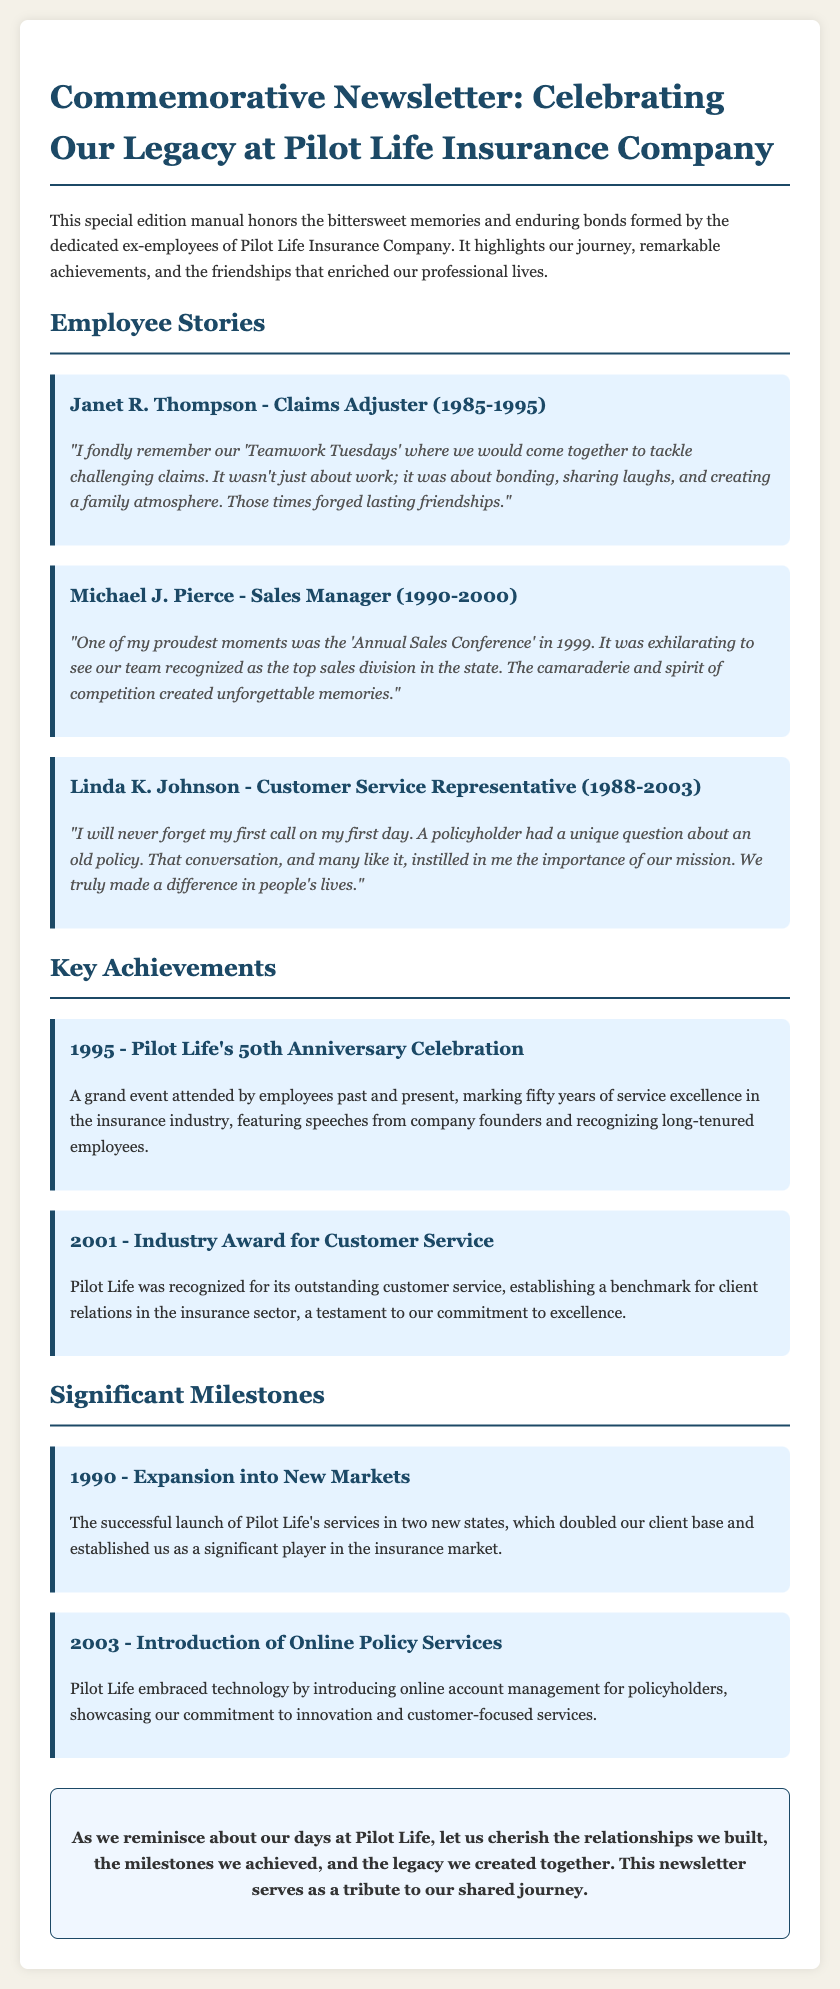What is the title of the newsletter? The title of the newsletter is stated in the header of the document.
Answer: Commemorative Newsletter: Celebrating Our Legacy at Pilot Life Insurance Company Who reminisced about 'Teamwork Tuesdays'? This person's memories are documented under the Employee Stories section.
Answer: Janet R. Thompson In which year was the 50th Anniversary Celebration held? The year of the anniversary celebration is presented under Key Achievements.
Answer: 1995 What significant event happened in 2001? This event is listed as a key achievement within the document.
Answer: Industry Award for Customer Service How many states did Pilot Life expand into in 1990? The information is provided under Significant Milestones.
Answer: Two What was introduced in 2003 to showcase innovation? This detail is included in the milestones section of the document.
Answer: Online Policy Services Which employee served as a Sales Manager? The job title is featured in the Employee Stories section.
Answer: Michael J. Pierce What atmosphere was created during 'Teamwork Tuesdays'? This response is derived from Janet R. Thompson's story.
Answer: Family atmosphere Who shared a memory about their first call on their first day? The employee's name is found under the Employee Stories section.
Answer: Linda K. Johnson 